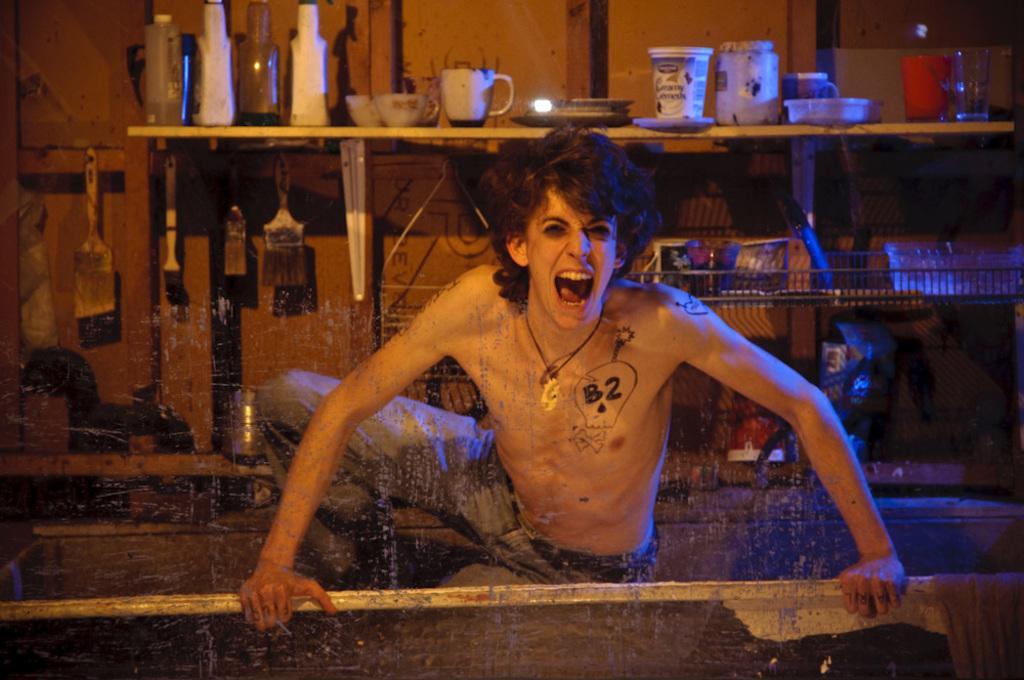How would you summarize this image in a sentence or two? In this image there is a man wearing a trousers and holding a hand grill and shouting. In the background there are some shelves. On the shelves there are cup, jars, spoons, brushes and books etc. 